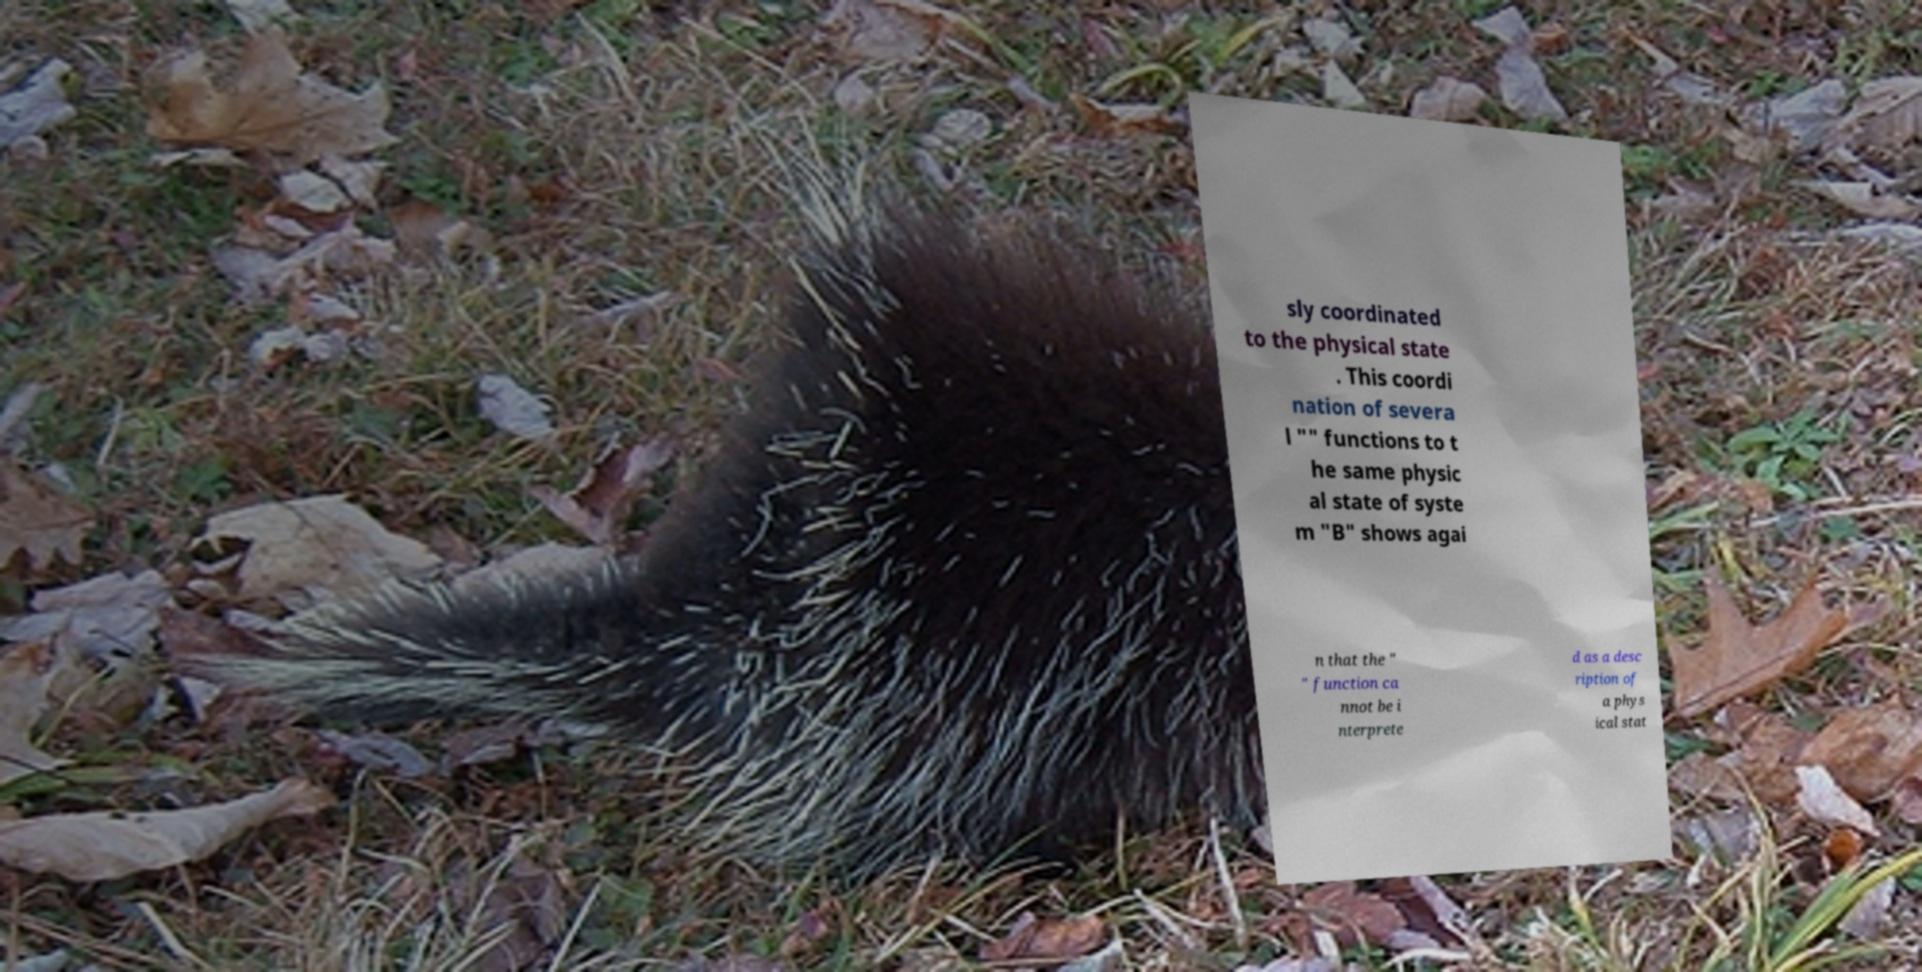I need the written content from this picture converted into text. Can you do that? sly coordinated to the physical state . This coordi nation of severa l "" functions to t he same physic al state of syste m "B" shows agai n that the " " function ca nnot be i nterprete d as a desc ription of a phys ical stat 